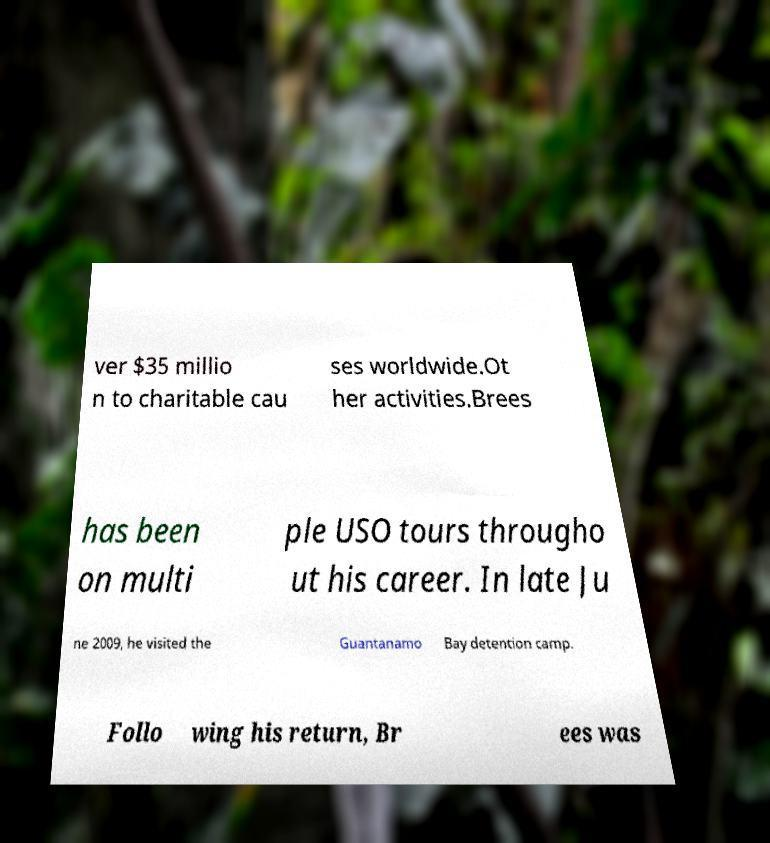Could you extract and type out the text from this image? ver $35 millio n to charitable cau ses worldwide.Ot her activities.Brees has been on multi ple USO tours througho ut his career. In late Ju ne 2009, he visited the Guantanamo Bay detention camp. Follo wing his return, Br ees was 